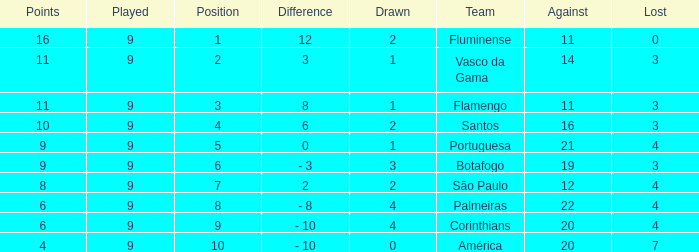Which Position has a Played larger than 9? None. 